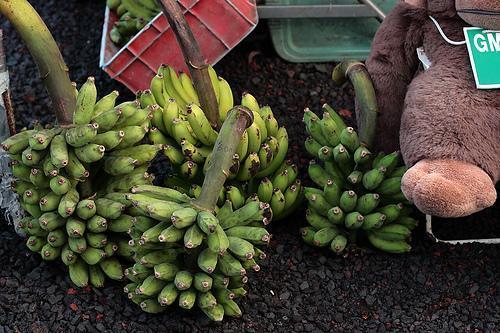How many bananas are there?
Give a very brief answer. 4. 